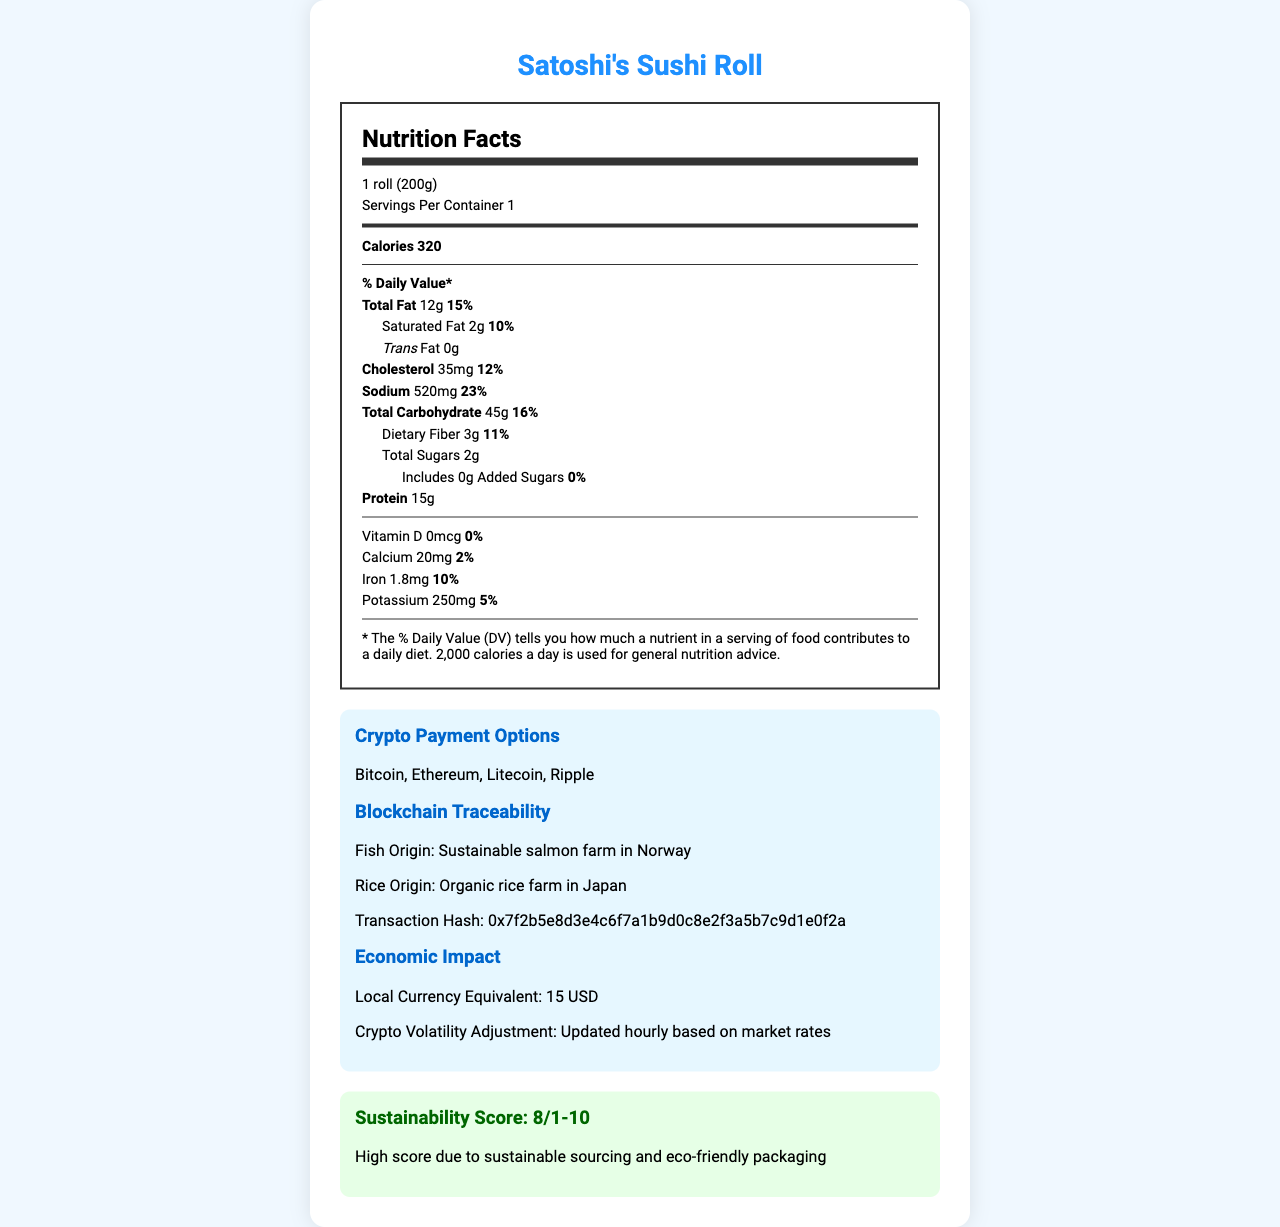what is the serving size of Satoshi's Sushi Roll? The serving size is mentioned directly under the heading "Nutrition Facts".
Answer: 1 roll (200g) how many calories are in one serving of Satoshi's Sushi Roll? The calorie count (320) is shown prominently in the nutrition label section under "Calories".
Answer: 320 what percent of the daily value for total fat does one serving contain? This can be found right next to the total fat amount (12g), which specifies that it provides 15% of the daily value.
Answer: 15% is there any trans fat in Satoshi's Sushi Roll? The label explicitly states that the trans fat amount is 0g.
Answer: No how many grams of protein are in one serving? The document lists protein content as 15g under protein.
Answer: 15g which is the origin of the salmon used in Satoshi's Sushi Roll? This information is provided in the Blockchain Traceability section.
Answer: Sustainable salmon farm in Norway what allergens are listed for Satoshi's Sushi Roll? The document lists Fish, Milk, Soy, and Sesame under the allergens section.
Answer: Fish, Milk, Soy, Sesame how many servings are there per container? This is listed under "Servings Per Container" in the nutrition label section.
Answer: 1 how does the restaurant update prices for cryptocurrency payments? This is stated under the "Crypto Volatility Adjustment" in the economic impact section.
Answer: Updated hourly based on market rates what is the sustainability score of the product? The sustainability score is given as 8 out of 10 in the sustainability section.
Answer: 8/10 how much vitamin D does one serving of Satoshi's Sushi Roll provide? The document shows that vitamin D content is 0 mcg.
Answer: 0 mcg which cryptocurrency is not accepted as a payment option? A. Bitcoin B. Ethereum C. Dogecoin D. Litecoin The document lists Bitcoin, Ethereum, Litecoin, and Ripple, but not Dogecoin, in the crypto payment options section.
Answer: C which of the following provides the highest daily value percentage? A. Sodium B. Calcium C. Protein D. Iron Protein provides the highest daily value percentage at 30%, compared to Sodium (23%), Calcium (2%), and Iron (10%).
Answer: C does the document list added sugars in Satoshi's Sushi Roll? The document lists 0g of added sugars under total sugars.
Answer: Yes how does the document describe the sustainability of Satoshi's Sushi Roll? The description is found in the sustainability score section.
Answer: High score due to sustainable sourcing and eco-friendly packaging what is the local currency equivalent price of Satoshi's Sushi Roll? Found under the economic impact section as the local currency equivalent.
Answer: 15 USD what ingredients are used in Satoshi's Sushi Roll? The ingredients are listed directly in the document.
Answer: Sushi rice, Nori (seaweed), Fresh salmon, Avocado, Cucumber, Cream cheese, Sesame seeds, Soy sauce, Wasabi, Pickled ginger how many total sugars are in one serving of Satoshi's Sushi Roll? This can be found under "Total Sugars" in the nutrition label section.
Answer: 2g is there enough information to determine the overall sales of the restaurant chain? The document does not provide any data related to the restaurant chain's sales.
Answer: Not enough information summarize the main idea of the document. The document serves to inform consumers about the nutritional content, sustainability, and crypto-friendly features of Satoshi's Sushi Roll while emphasizing transparency and traceability through blockchain technology.
Answer: The document provides a detailed nutritional breakdown of Satoshi's Sushi Roll, including calories, macronutrient content, and daily values. It highlights the sustainable sourcing of ingredients and eco-friendly packaging, along with crypto payment options and the economic impact of cryptocurrency volatility. Additionally, it includes allergen information and blockchain traceability of key ingredients. 